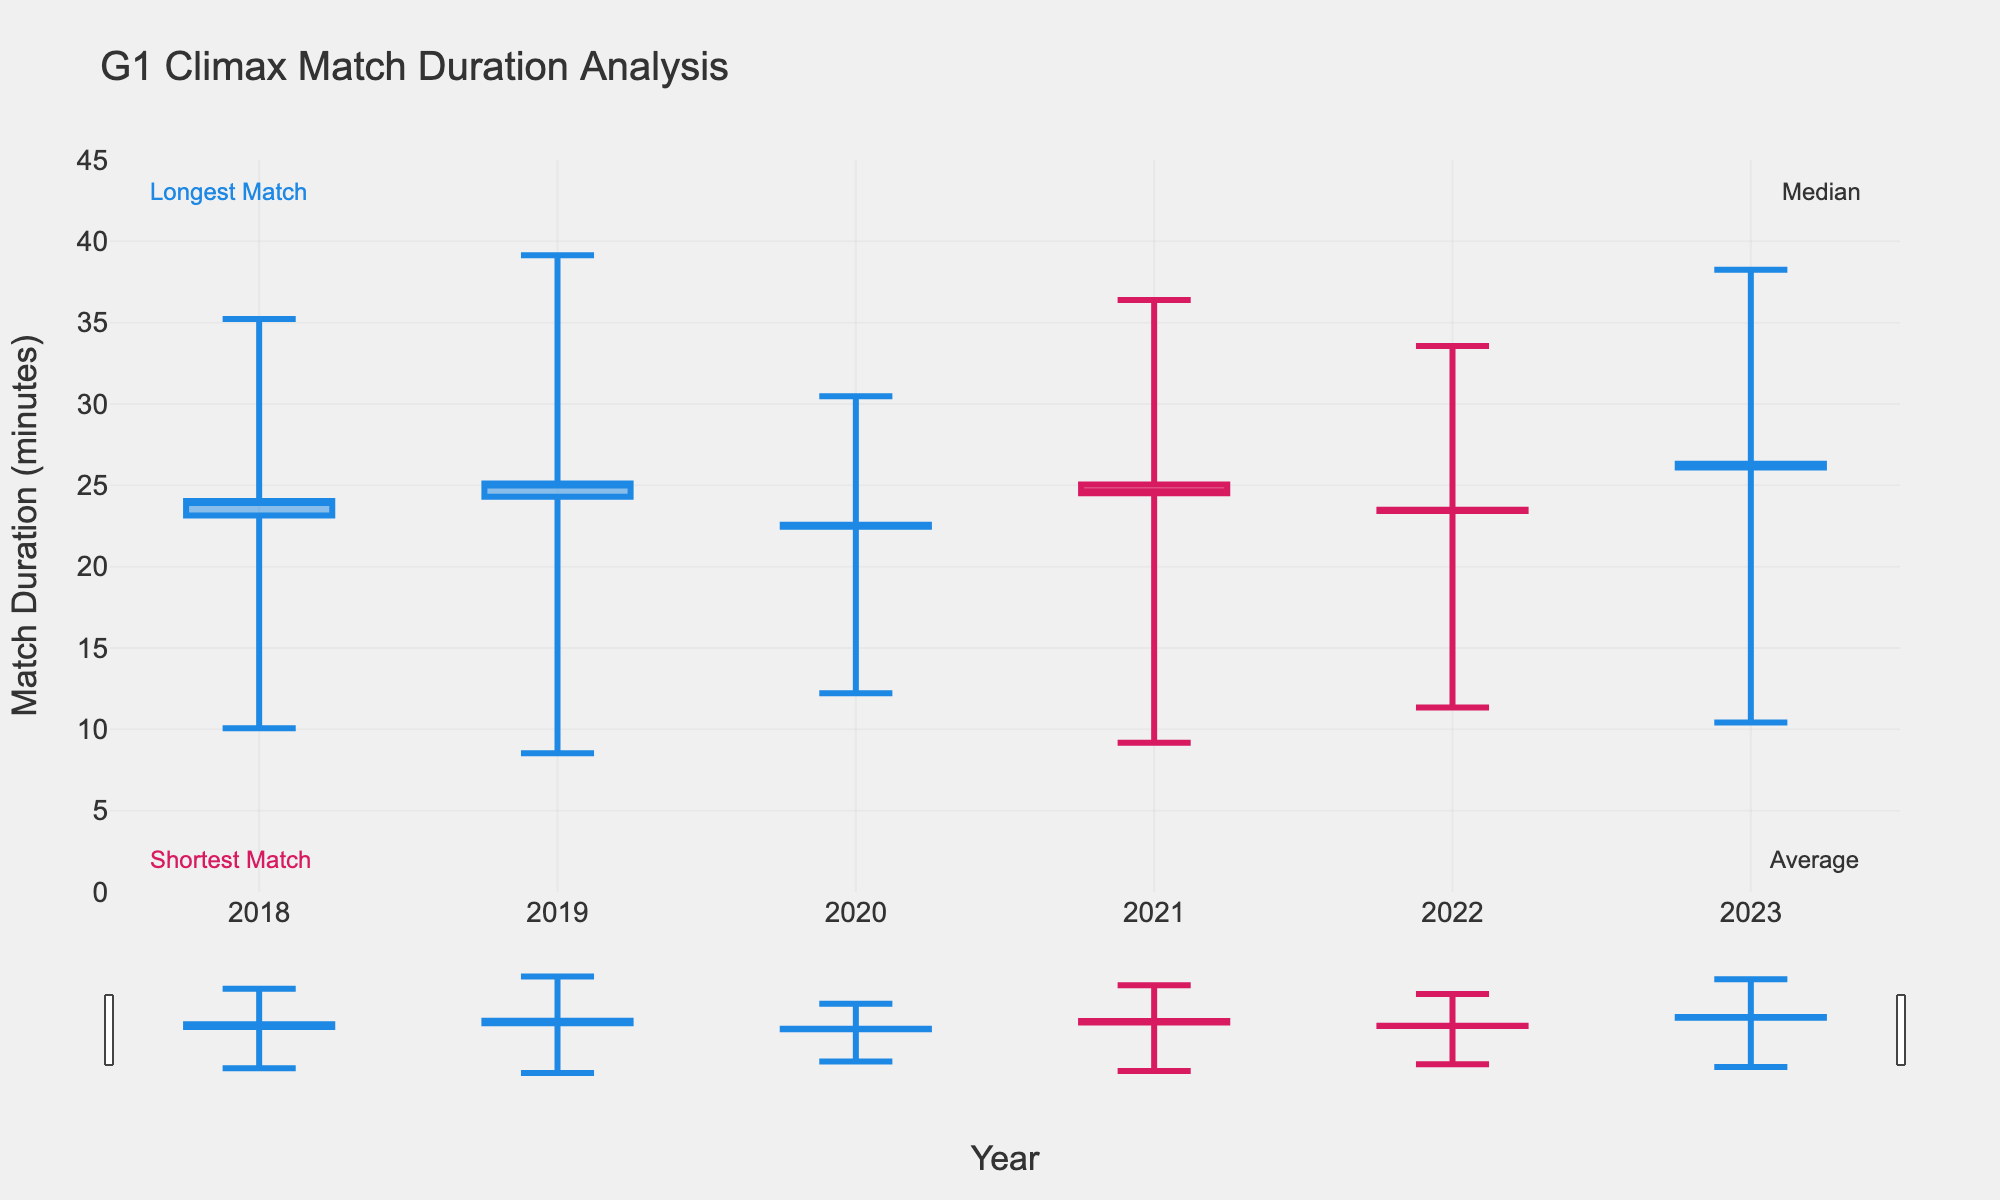What's the title of the figure? The title of the figure is displayed at the top of the chart, and it reads "G1 Climax Match Duration Analysis".
Answer: G1 Climax Match Duration Analysis Which year had the shortest match in the data? By looking at the lowest point for the 'Shortest' data in the chart, the shortest match duration can be identified. The lowest 'Shortest' match is for the year 2019, which goes down to 8.53 minutes.
Answer: 2019 How did the median match duration in 2023 compare to 2022? The median match duration is marked by the opening point of the candlestick. For 2023, the median is at 26.10 minutes, while for 2022, the median is at 23.50 minutes. Comparing these values, 2023 has a higher median match duration than 2022.
Answer: 2023 is higher What is the average match duration in 2021? The average match duration corresponds to the closing point of the candlestick. For 2021, it is at 24.52 minutes.
Answer: 24.52 minutes Which year had the longest match? The highest point on the chart for the 'Longest' category indicates the longest match duration. The year with the highest point is 2019, with a duration of 39.15 minutes.
Answer: 2019 How does the longest match in 2018 compare to 2020? Looking at the highest points for 2018 and 2020, the longest match durations are 35.22 and 30.48 minutes, respectively. Comparing these, the longest match in 2018 was longer than in 2020.
Answer: 2018 is longer What is the difference between the longest and shortest match durations in 2022? The longest match duration in 2022 is 33.57 minutes, and the shortest match duration is 11.35 minutes. The difference is calculated as 33.57 - 11.35.
Answer: 22.22 minutes Which year had the median match duration closest to 25 minutes? Checking the median values for each year, we see 2018 (23.15), 2019 (24.30), 2020 (22.45), 2021 (25.05), 2022 (23.50), and 2023 (26.10). The median match duration closest to 25 minutes is in 2021, at 25.05 minutes.
Answer: 2021 What is the range of match durations (difference between longest and shortest) in 2019? The longest match duration in 2019 is 39.15 minutes, and the shortest is 8.53 minutes. The range is calculated as 39.15 - 8.53.
Answer: 30.62 minutes What trend can be observed in the average match duration from 2020 to 2023? Observing the closing points from 2020 to 2023, the average match durations are 22.57 (2020), 24.52 (2021), 23.42 (2022), and 26.33 (2023). We can see a general increasing trend in the average match duration over these years.
Answer: Increasing trend 